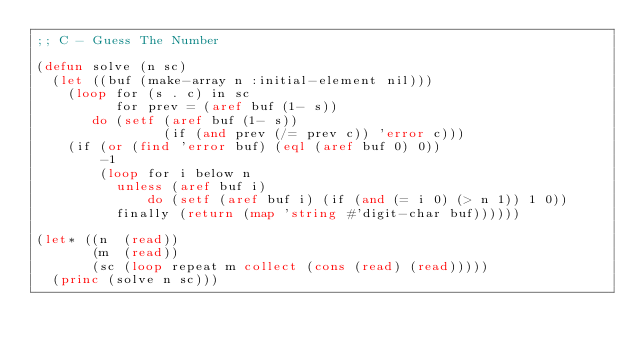<code> <loc_0><loc_0><loc_500><loc_500><_Lisp_>;; C - Guess The Number

(defun solve (n sc)
  (let ((buf (make-array n :initial-element nil)))
    (loop for (s . c) in sc
          for prev = (aref buf (1- s))
       do (setf (aref buf (1- s))
                (if (and prev (/= prev c)) 'error c)))
    (if (or (find 'error buf) (eql (aref buf 0) 0))
        -1
        (loop for i below n
          unless (aref buf i)
              do (setf (aref buf i) (if (and (= i 0) (> n 1)) 1 0))
          finally (return (map 'string #'digit-char buf))))))

(let* ((n  (read))
       (m  (read))
       (sc (loop repeat m collect (cons (read) (read)))))
  (princ (solve n sc)))
</code> 